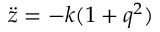<formula> <loc_0><loc_0><loc_500><loc_500>\ddot { z } = - k ( 1 + q ^ { 2 } )</formula> 